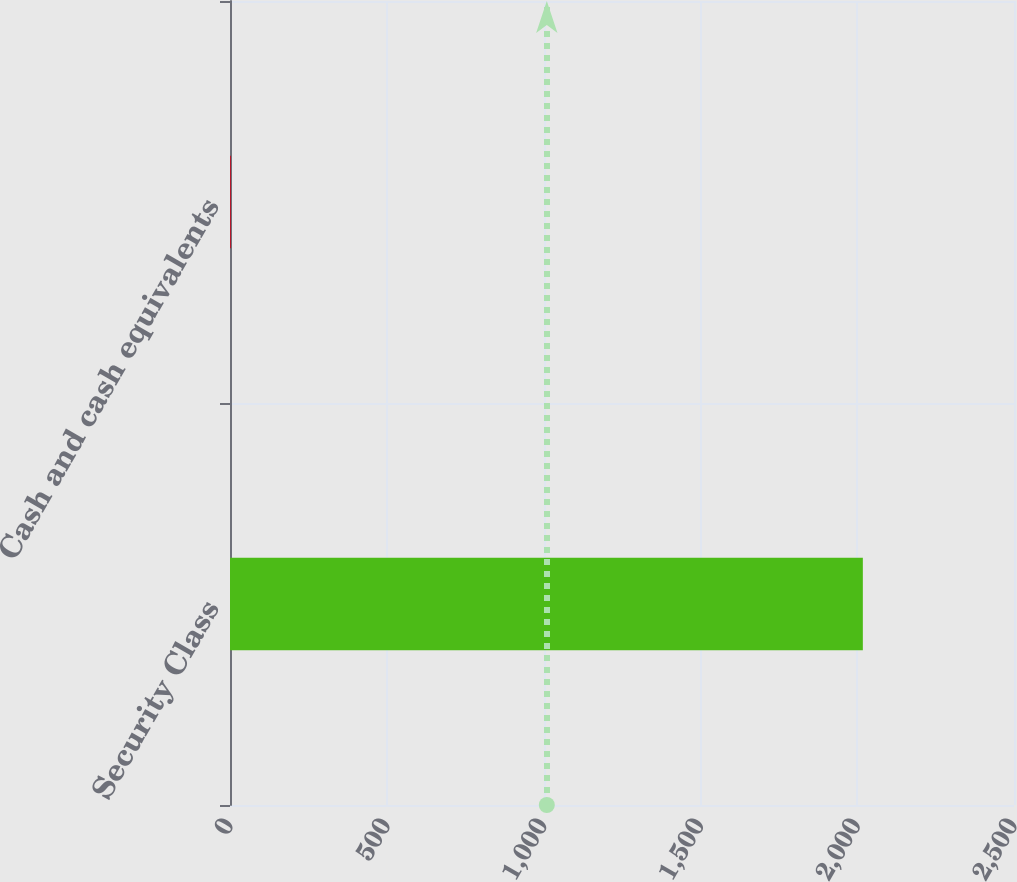Convert chart to OTSL. <chart><loc_0><loc_0><loc_500><loc_500><bar_chart><fcel>Security Class<fcel>Cash and cash equivalents<nl><fcel>2018<fcel>2.5<nl></chart> 